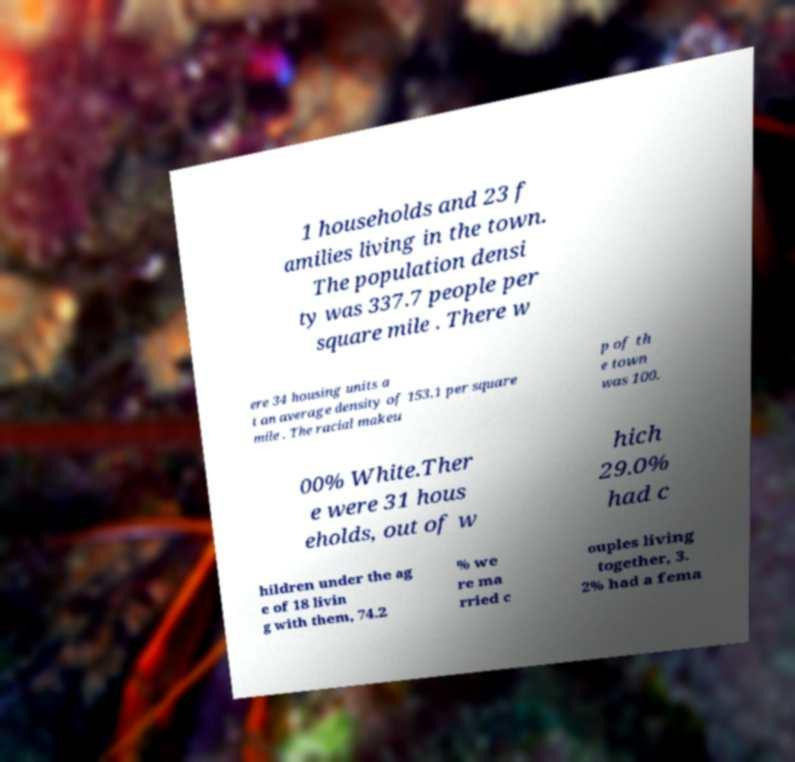I need the written content from this picture converted into text. Can you do that? 1 households and 23 f amilies living in the town. The population densi ty was 337.7 people per square mile . There w ere 34 housing units a t an average density of 153.1 per square mile . The racial makeu p of th e town was 100. 00% White.Ther e were 31 hous eholds, out of w hich 29.0% had c hildren under the ag e of 18 livin g with them, 74.2 % we re ma rried c ouples living together, 3. 2% had a fema 